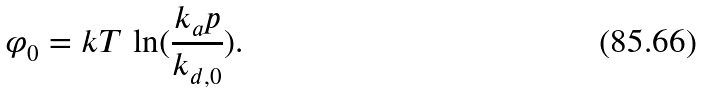Convert formula to latex. <formula><loc_0><loc_0><loc_500><loc_500>\varphi _ { 0 } = k T \, \ln ( \frac { k _ { a } p } { k _ { d , 0 } } ) .</formula> 